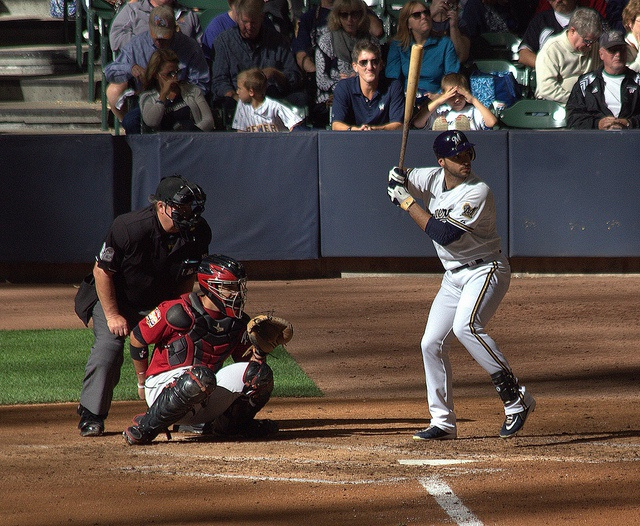Describe the objects in this image and their specific colors. I can see people in black, maroon, gray, and white tones, people in black, white, gray, and darkgray tones, people in black, gray, brown, and maroon tones, people in black, gray, and maroon tones, and people in black, navy, salmon, and gray tones in this image. 